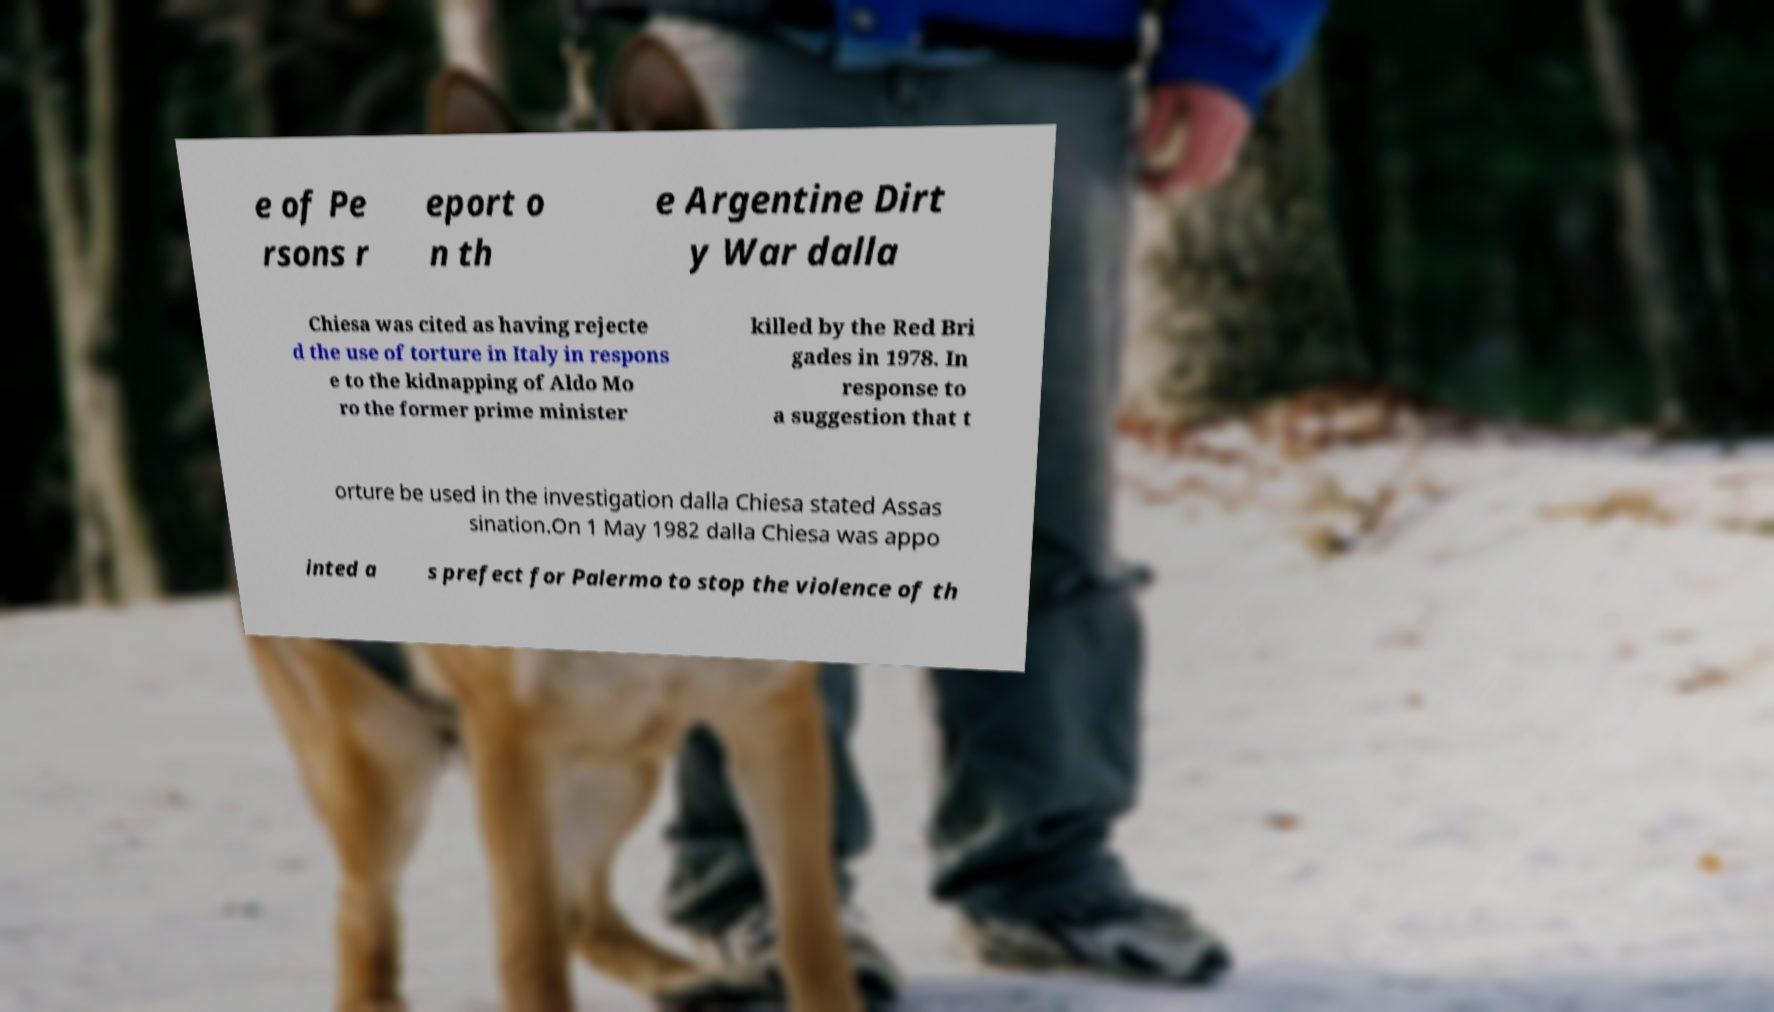There's text embedded in this image that I need extracted. Can you transcribe it verbatim? e of Pe rsons r eport o n th e Argentine Dirt y War dalla Chiesa was cited as having rejecte d the use of torture in Italy in respons e to the kidnapping of Aldo Mo ro the former prime minister killed by the Red Bri gades in 1978. In response to a suggestion that t orture be used in the investigation dalla Chiesa stated Assas sination.On 1 May 1982 dalla Chiesa was appo inted a s prefect for Palermo to stop the violence of th 